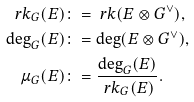Convert formula to latex. <formula><loc_0><loc_0><loc_500><loc_500>\ r k _ { G } ( E ) \colon & = \ r k ( E \otimes G ^ { \vee } ) , \\ \deg _ { G } ( E ) \colon & = \deg ( E \otimes G ^ { \vee } ) , \\ \mu _ { G } ( E ) \colon & = \frac { \deg _ { G } ( E ) } { \ r k _ { G } ( E ) } .</formula> 